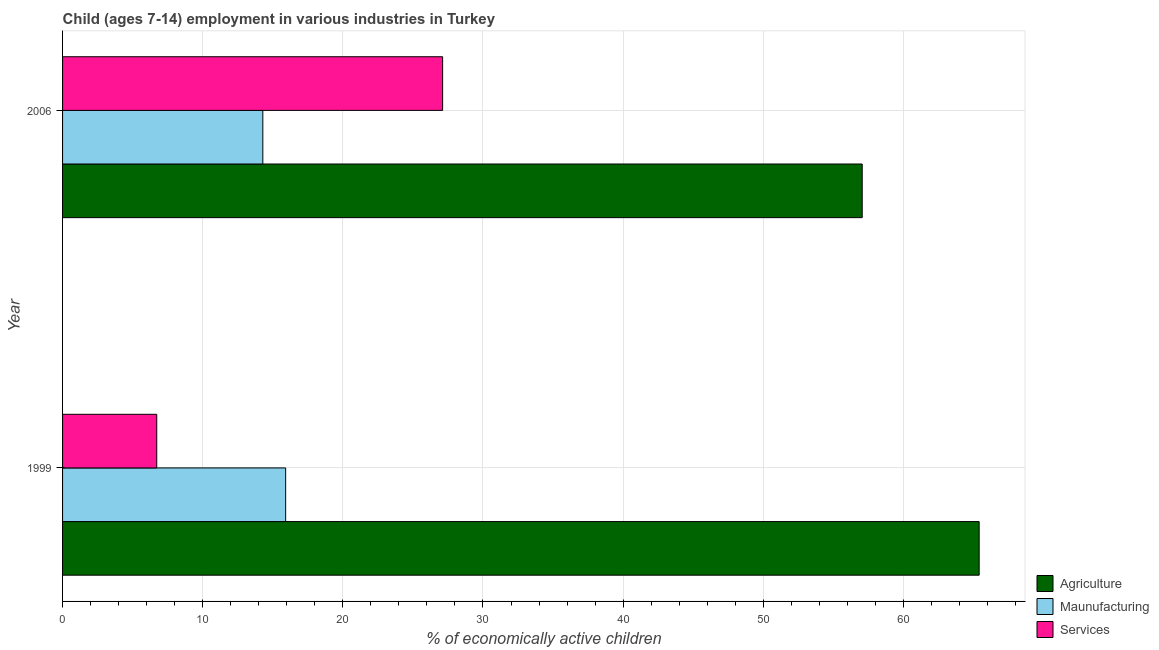How many groups of bars are there?
Your response must be concise. 2. Are the number of bars per tick equal to the number of legend labels?
Offer a very short reply. Yes. Are the number of bars on each tick of the Y-axis equal?
Offer a very short reply. Yes. How many bars are there on the 2nd tick from the top?
Provide a succinct answer. 3. What is the label of the 1st group of bars from the top?
Keep it short and to the point. 2006. In how many cases, is the number of bars for a given year not equal to the number of legend labels?
Offer a terse response. 0. What is the percentage of economically active children in agriculture in 2006?
Your response must be concise. 57.06. Across all years, what is the maximum percentage of economically active children in manufacturing?
Your answer should be very brief. 15.92. Across all years, what is the minimum percentage of economically active children in agriculture?
Provide a short and direct response. 57.06. In which year was the percentage of economically active children in agriculture minimum?
Offer a very short reply. 2006. What is the total percentage of economically active children in agriculture in the graph?
Your answer should be compact. 122.47. What is the difference between the percentage of economically active children in manufacturing in 1999 and that in 2006?
Make the answer very short. 1.63. What is the difference between the percentage of economically active children in services in 2006 and the percentage of economically active children in agriculture in 1999?
Provide a succinct answer. -38.29. What is the average percentage of economically active children in services per year?
Your answer should be compact. 16.92. In the year 2006, what is the difference between the percentage of economically active children in manufacturing and percentage of economically active children in services?
Provide a succinct answer. -12.83. In how many years, is the percentage of economically active children in services greater than 48 %?
Offer a terse response. 0. What is the ratio of the percentage of economically active children in agriculture in 1999 to that in 2006?
Ensure brevity in your answer.  1.15. Is the difference between the percentage of economically active children in agriculture in 1999 and 2006 greater than the difference between the percentage of economically active children in manufacturing in 1999 and 2006?
Ensure brevity in your answer.  Yes. In how many years, is the percentage of economically active children in manufacturing greater than the average percentage of economically active children in manufacturing taken over all years?
Offer a terse response. 1. What does the 3rd bar from the top in 1999 represents?
Offer a terse response. Agriculture. What does the 1st bar from the bottom in 1999 represents?
Provide a succinct answer. Agriculture. Is it the case that in every year, the sum of the percentage of economically active children in agriculture and percentage of economically active children in manufacturing is greater than the percentage of economically active children in services?
Provide a succinct answer. Yes. How many bars are there?
Offer a very short reply. 6. What is the difference between two consecutive major ticks on the X-axis?
Your answer should be compact. 10. How are the legend labels stacked?
Keep it short and to the point. Vertical. What is the title of the graph?
Your response must be concise. Child (ages 7-14) employment in various industries in Turkey. Does "Methane" appear as one of the legend labels in the graph?
Offer a very short reply. No. What is the label or title of the X-axis?
Provide a short and direct response. % of economically active children. What is the label or title of the Y-axis?
Provide a short and direct response. Year. What is the % of economically active children in Agriculture in 1999?
Provide a short and direct response. 65.41. What is the % of economically active children in Maunufacturing in 1999?
Make the answer very short. 15.92. What is the % of economically active children in Services in 1999?
Provide a succinct answer. 6.72. What is the % of economically active children of Agriculture in 2006?
Give a very brief answer. 57.06. What is the % of economically active children of Maunufacturing in 2006?
Provide a succinct answer. 14.29. What is the % of economically active children in Services in 2006?
Your response must be concise. 27.12. Across all years, what is the maximum % of economically active children in Agriculture?
Make the answer very short. 65.41. Across all years, what is the maximum % of economically active children in Maunufacturing?
Your answer should be very brief. 15.92. Across all years, what is the maximum % of economically active children of Services?
Your answer should be compact. 27.12. Across all years, what is the minimum % of economically active children of Agriculture?
Provide a succinct answer. 57.06. Across all years, what is the minimum % of economically active children of Maunufacturing?
Your response must be concise. 14.29. Across all years, what is the minimum % of economically active children of Services?
Your answer should be compact. 6.72. What is the total % of economically active children of Agriculture in the graph?
Offer a very short reply. 122.47. What is the total % of economically active children of Maunufacturing in the graph?
Your answer should be very brief. 30.21. What is the total % of economically active children in Services in the graph?
Keep it short and to the point. 33.84. What is the difference between the % of economically active children of Agriculture in 1999 and that in 2006?
Provide a short and direct response. 8.35. What is the difference between the % of economically active children in Maunufacturing in 1999 and that in 2006?
Make the answer very short. 1.63. What is the difference between the % of economically active children in Services in 1999 and that in 2006?
Your response must be concise. -20.4. What is the difference between the % of economically active children in Agriculture in 1999 and the % of economically active children in Maunufacturing in 2006?
Give a very brief answer. 51.12. What is the difference between the % of economically active children of Agriculture in 1999 and the % of economically active children of Services in 2006?
Your response must be concise. 38.29. What is the difference between the % of economically active children in Maunufacturing in 1999 and the % of economically active children in Services in 2006?
Keep it short and to the point. -11.2. What is the average % of economically active children of Agriculture per year?
Ensure brevity in your answer.  61.23. What is the average % of economically active children in Maunufacturing per year?
Make the answer very short. 15.1. What is the average % of economically active children of Services per year?
Ensure brevity in your answer.  16.92. In the year 1999, what is the difference between the % of economically active children of Agriculture and % of economically active children of Maunufacturing?
Make the answer very short. 49.49. In the year 1999, what is the difference between the % of economically active children in Agriculture and % of economically active children in Services?
Provide a short and direct response. 58.68. In the year 1999, what is the difference between the % of economically active children of Maunufacturing and % of economically active children of Services?
Make the answer very short. 9.2. In the year 2006, what is the difference between the % of economically active children in Agriculture and % of economically active children in Maunufacturing?
Your answer should be compact. 42.77. In the year 2006, what is the difference between the % of economically active children of Agriculture and % of economically active children of Services?
Give a very brief answer. 29.94. In the year 2006, what is the difference between the % of economically active children of Maunufacturing and % of economically active children of Services?
Your response must be concise. -12.83. What is the ratio of the % of economically active children in Agriculture in 1999 to that in 2006?
Make the answer very short. 1.15. What is the ratio of the % of economically active children of Maunufacturing in 1999 to that in 2006?
Your answer should be compact. 1.11. What is the ratio of the % of economically active children in Services in 1999 to that in 2006?
Make the answer very short. 0.25. What is the difference between the highest and the second highest % of economically active children in Agriculture?
Provide a succinct answer. 8.35. What is the difference between the highest and the second highest % of economically active children in Maunufacturing?
Your answer should be very brief. 1.63. What is the difference between the highest and the second highest % of economically active children in Services?
Offer a terse response. 20.4. What is the difference between the highest and the lowest % of economically active children of Agriculture?
Your answer should be very brief. 8.35. What is the difference between the highest and the lowest % of economically active children of Maunufacturing?
Give a very brief answer. 1.63. What is the difference between the highest and the lowest % of economically active children of Services?
Give a very brief answer. 20.4. 